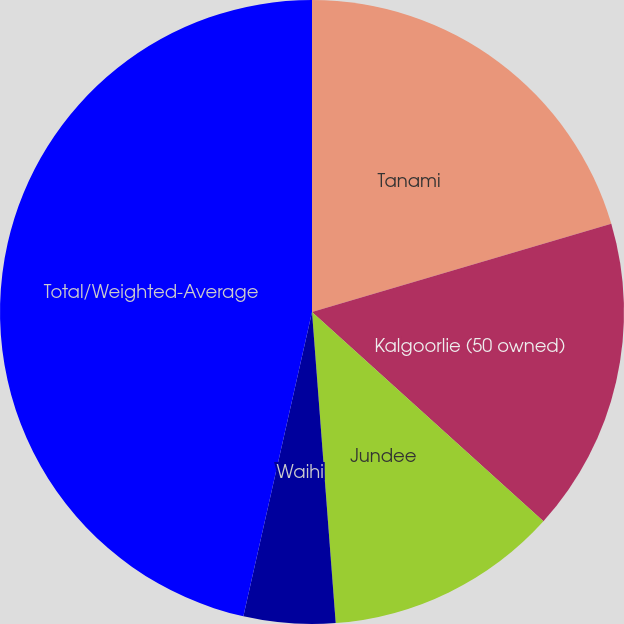Convert chart. <chart><loc_0><loc_0><loc_500><loc_500><pie_chart><fcel>Tanami<fcel>Kalgoorlie (50 owned)<fcel>Jundee<fcel>Waihi<fcel>Total/Weighted-Average<nl><fcel>20.44%<fcel>16.26%<fcel>12.09%<fcel>4.74%<fcel>46.47%<nl></chart> 